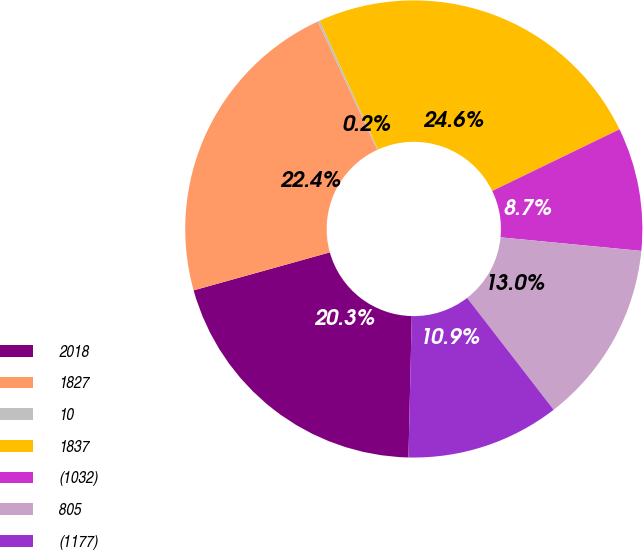Convert chart to OTSL. <chart><loc_0><loc_0><loc_500><loc_500><pie_chart><fcel>2018<fcel>1827<fcel>10<fcel>1837<fcel>(1032)<fcel>805<fcel>(1177)<nl><fcel>20.3%<fcel>22.43%<fcel>0.15%<fcel>24.57%<fcel>8.71%<fcel>12.99%<fcel>10.85%<nl></chart> 